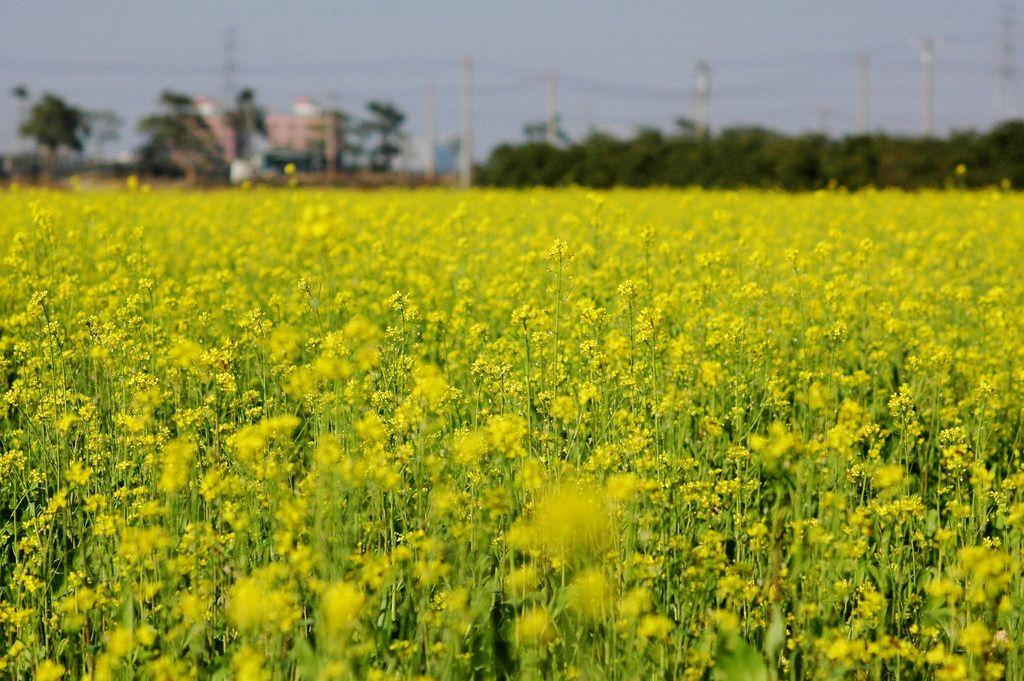What types of vegetation are at the bottom of the image? There are many plants and flowers at the bottom of the image. What can be seen in the middle of the image? There are trees, buildings, electric poles, cables, and the sky visible in the middle of the image. How many kittens are taking a bath in the image? There are no kittens or baths present in the image. Who is the partner of the person in the image? There is no person or partner mentioned in the image. 